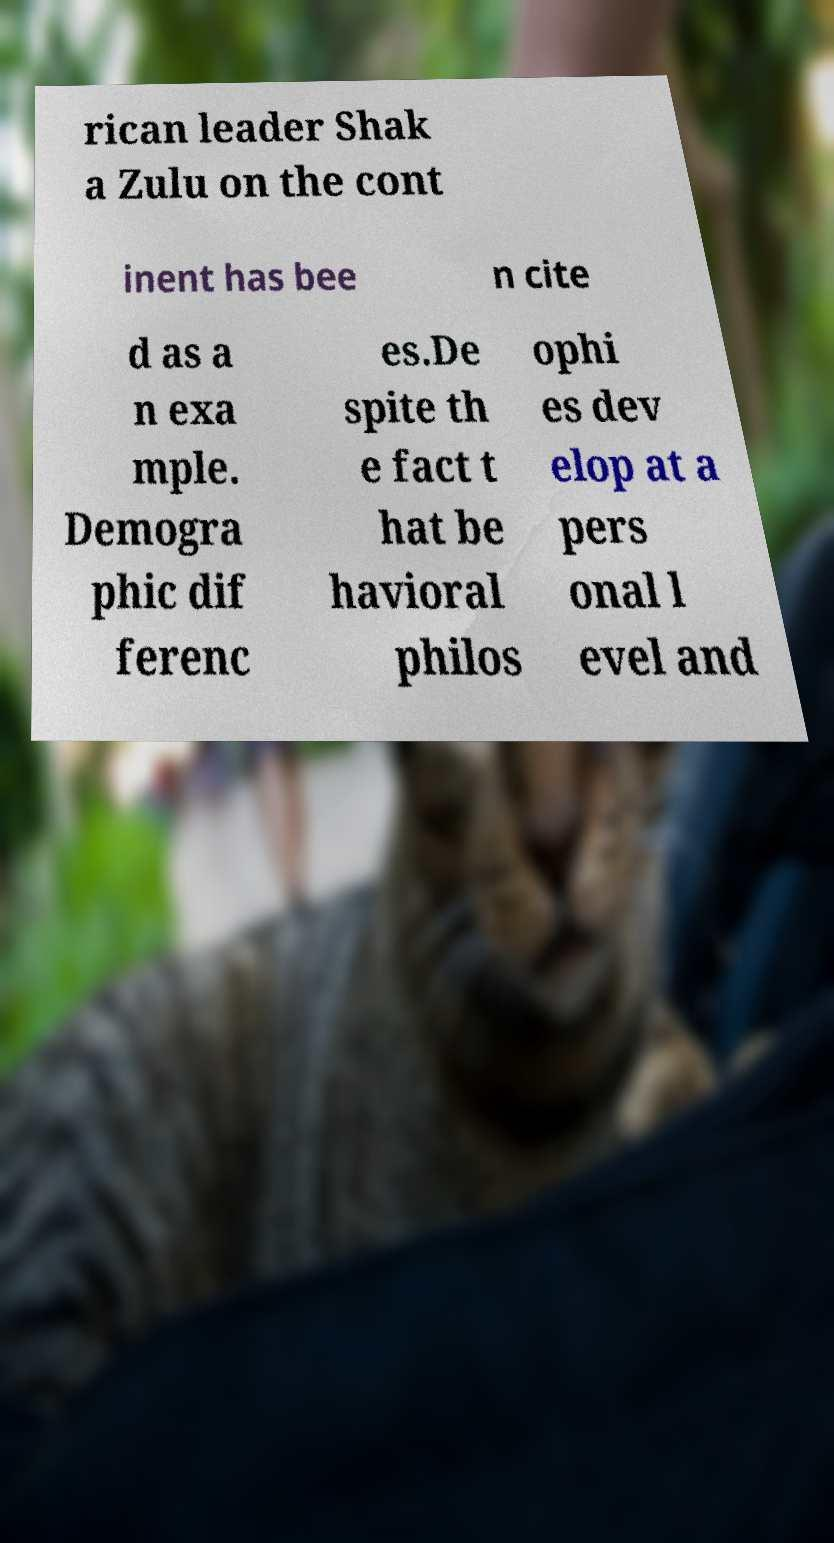There's text embedded in this image that I need extracted. Can you transcribe it verbatim? rican leader Shak a Zulu on the cont inent has bee n cite d as a n exa mple. Demogra phic dif ferenc es.De spite th e fact t hat be havioral philos ophi es dev elop at a pers onal l evel and 